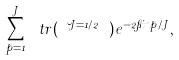Convert formula to latex. <formula><loc_0><loc_0><loc_500><loc_500>\sum _ { p = 1 } ^ { J } \ t r ( \cdots \lambda ^ { J = 1 / 2 } \cdots ) e ^ { - 2 \pi i n p / J } ,</formula> 